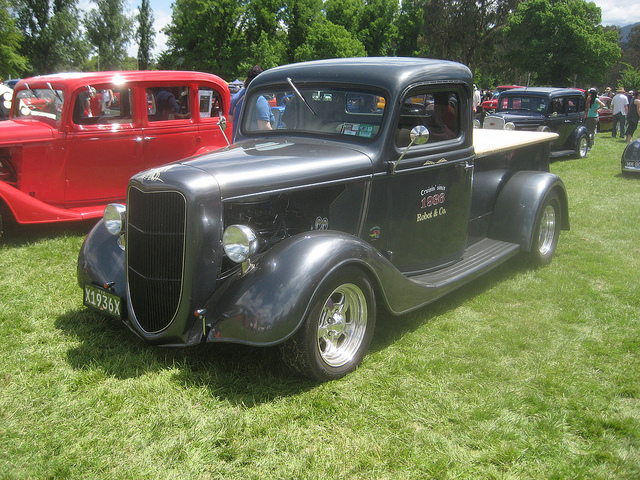Read and extract the text from this image. X1936X Robet Co. & 